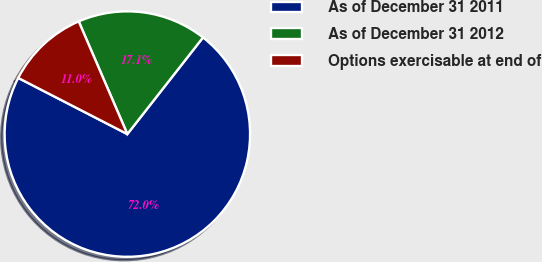Convert chart to OTSL. <chart><loc_0><loc_0><loc_500><loc_500><pie_chart><fcel>As of December 31 2011<fcel>As of December 31 2012<fcel>Options exercisable at end of<nl><fcel>71.99%<fcel>17.06%<fcel>10.95%<nl></chart> 